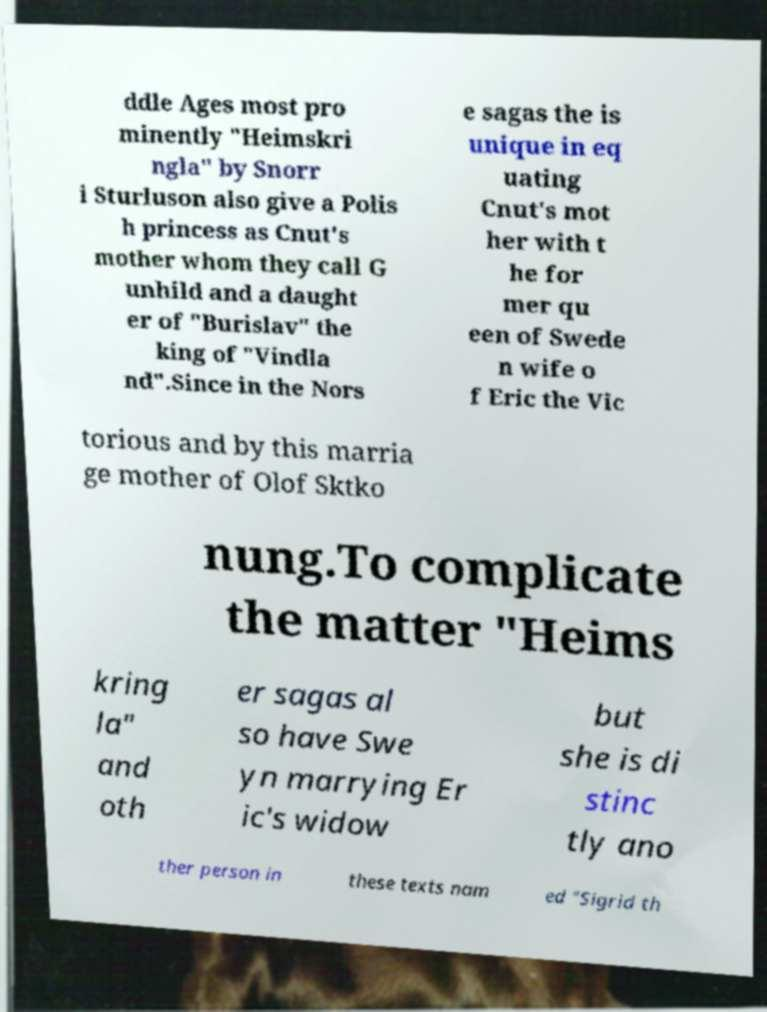Please identify and transcribe the text found in this image. ddle Ages most pro minently "Heimskri ngla" by Snorr i Sturluson also give a Polis h princess as Cnut's mother whom they call G unhild and a daught er of "Burislav" the king of "Vindla nd".Since in the Nors e sagas the is unique in eq uating Cnut's mot her with t he for mer qu een of Swede n wife o f Eric the Vic torious and by this marria ge mother of Olof Sktko nung.To complicate the matter "Heims kring la" and oth er sagas al so have Swe yn marrying Er ic's widow but she is di stinc tly ano ther person in these texts nam ed "Sigrid th 